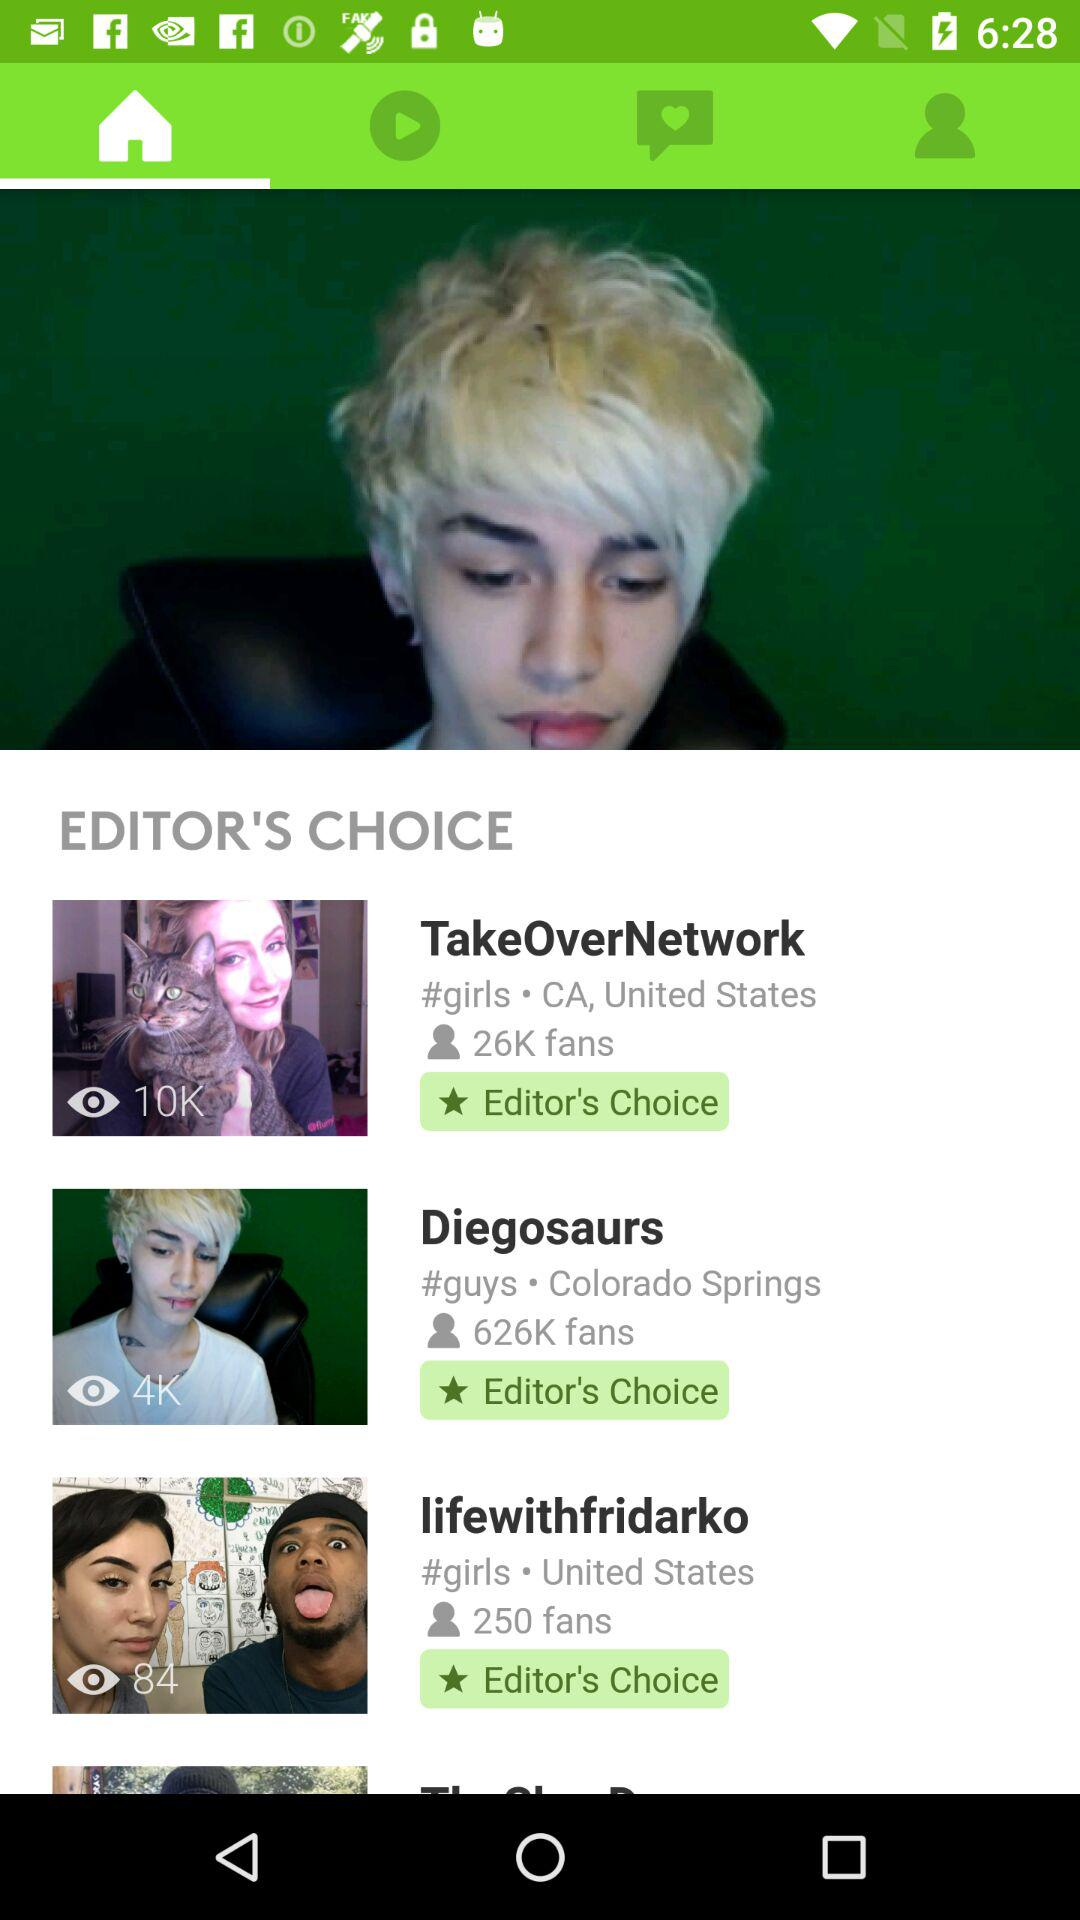How many Editor's Choice items are there?
Answer the question using a single word or phrase. 3 